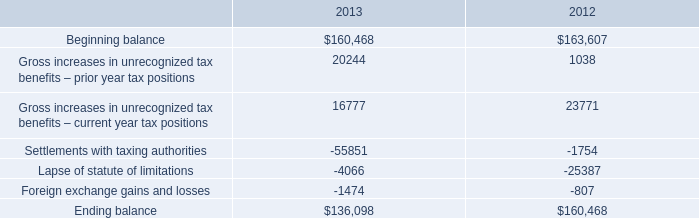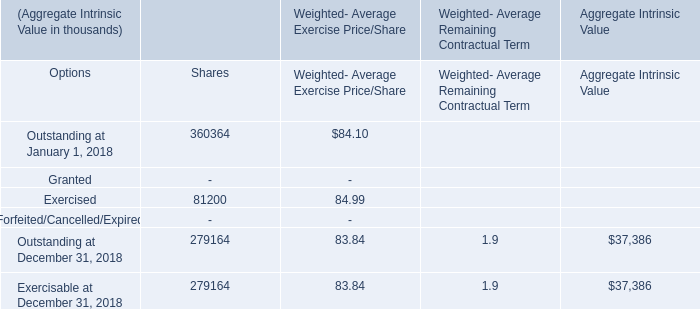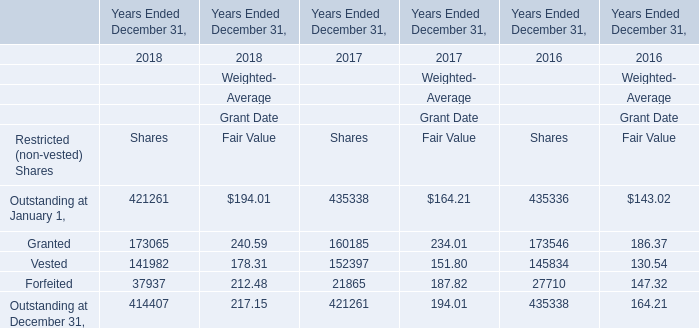what is the percentage change in total gross amount of unrecognized tax benefits from 2012 to 2013? 
Computations: ((136098 - 160468) / 160468)
Answer: -0.15187. What's the average of Ending balance of 2013, and Forfeited of Years Ended December 31, 2017 Shares ? 
Computations: ((136098.0 + 21865.0) / 2)
Answer: 78981.5. 